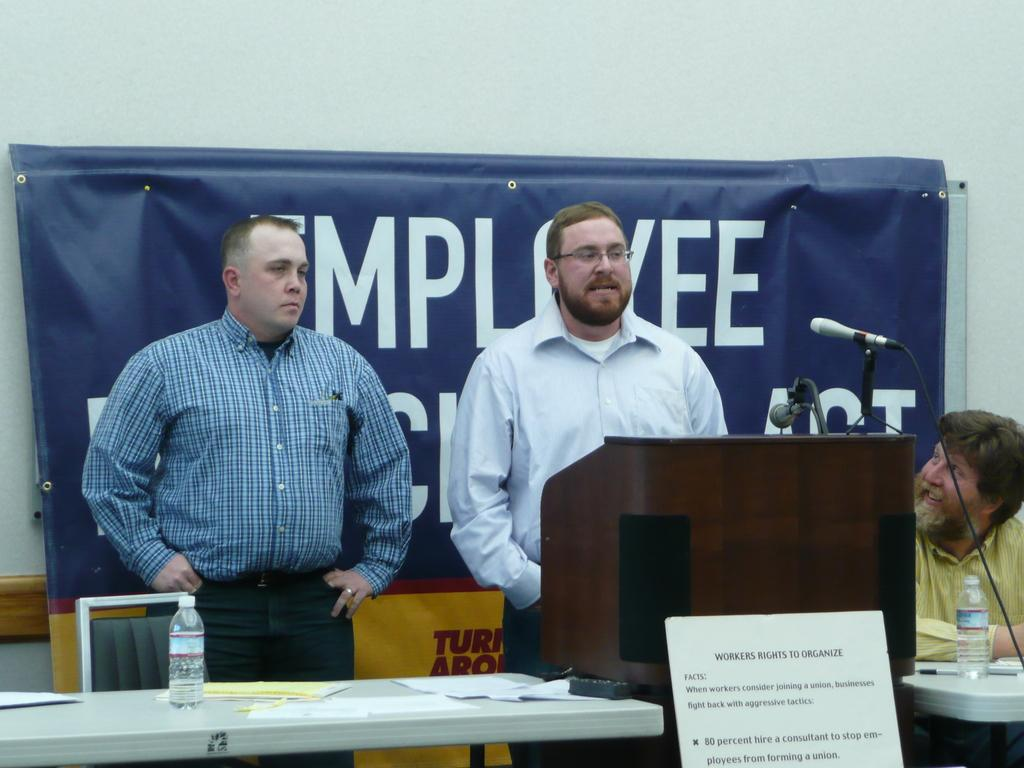What are the persons in the image doing? The persons in the image are standing on a table. What object can be seen in the image besides the persons on the table? There is a bottle in the image. What type of material is present in the image? There is paper in the image. What is the position of the person in the image? There is a person sitting in the image. What device is visible in the image? There is a microphone in the image. What can be seen in the background of the image? There is a poster in the background of the image. What type of thread is being used by the monkey in the image? There is no monkey present in the image, so there is no thread being used. How does the dog interact with the persons standing on the table in the image? There is no dog present in the image, so there is no interaction with the persons standing on the table. 